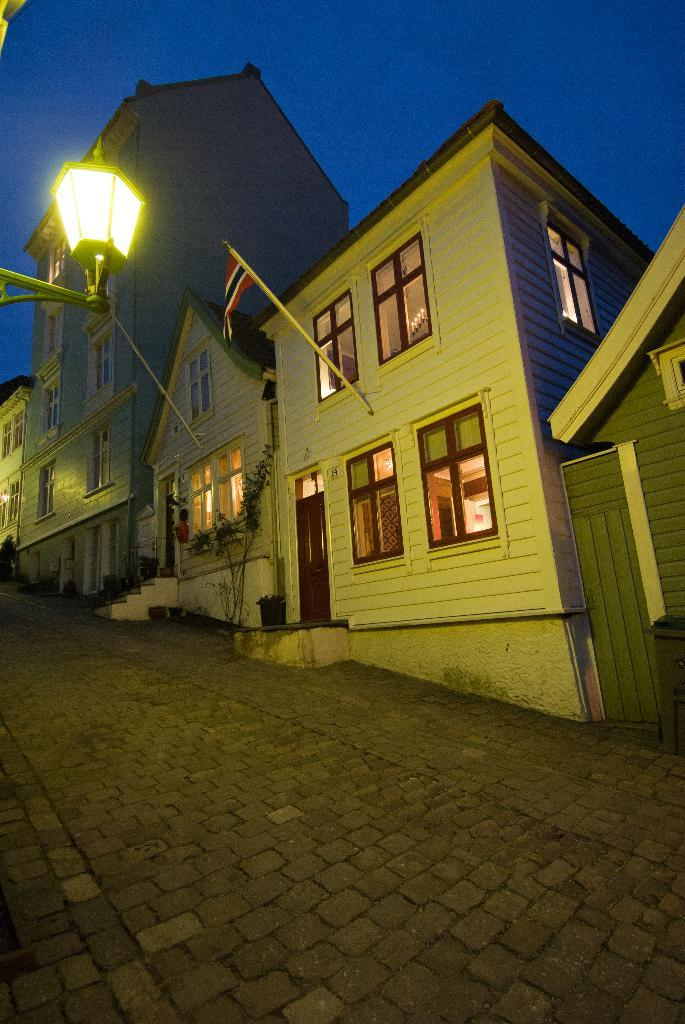What type of structures are visible in the image? There are houses with windows and doors in the image. What natural element is present in the image? There is a tree in the image. What objects are used for planting in the image? There are flower pots in the image. What is hanging from a pole in the image? There is a flag hanging from a pole in the image. What type of lighting is present in the image? There is a street lamp in the image. What type of division is taking place in the image? There is no division taking place in the image; it features houses, a tree, flower pots, a flag, and a street lamp. What type of coat is being worn by the tree in the image? There is no coat present in the image, as trees do not wear clothing. 